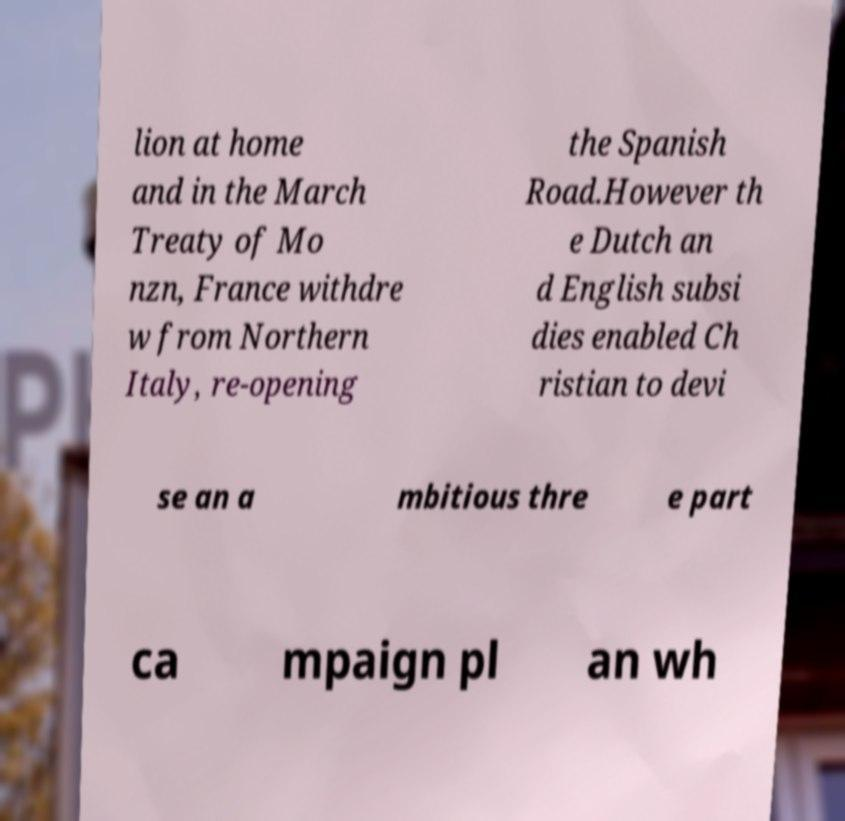Can you read and provide the text displayed in the image?This photo seems to have some interesting text. Can you extract and type it out for me? lion at home and in the March Treaty of Mo nzn, France withdre w from Northern Italy, re-opening the Spanish Road.However th e Dutch an d English subsi dies enabled Ch ristian to devi se an a mbitious thre e part ca mpaign pl an wh 